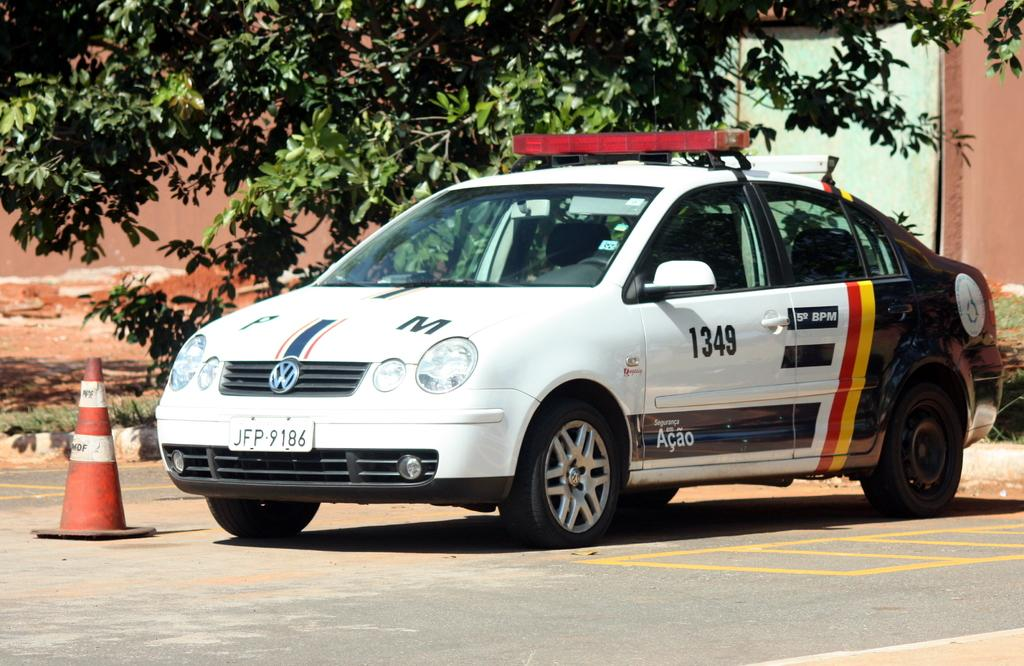What is the main subject of the image? The main subject of the image is a car on the road. What object is placed beside the car? There is a traffic cone beside the car. What type of natural elements can be seen in the image? Trees are visible at the top of the image. What type of structure is visible in the background? There is a building in the background of the image. What type of eggnog is being served in the car? There is no eggnog present in the image; it features a car on the road with a traffic cone beside it. What type of jeans is the driver wearing in the image? There is no driver visible in the image, and therefore no jeans can be observed. 